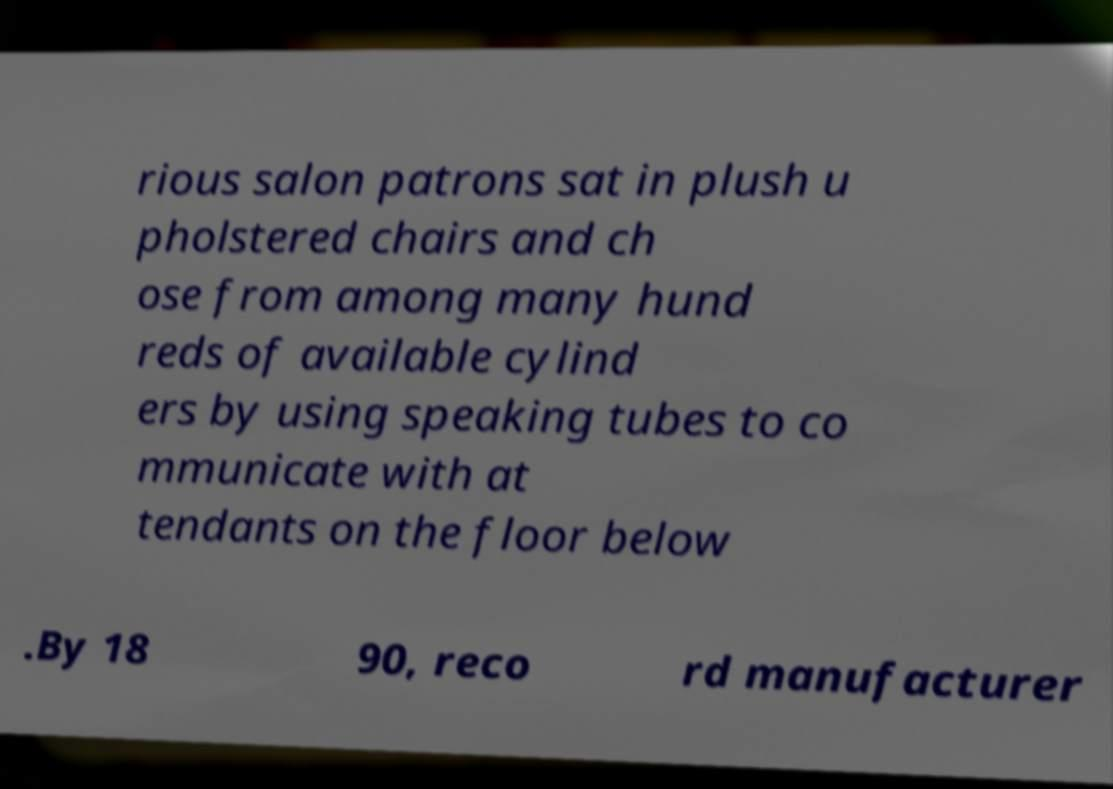There's text embedded in this image that I need extracted. Can you transcribe it verbatim? rious salon patrons sat in plush u pholstered chairs and ch ose from among many hund reds of available cylind ers by using speaking tubes to co mmunicate with at tendants on the floor below .By 18 90, reco rd manufacturer 